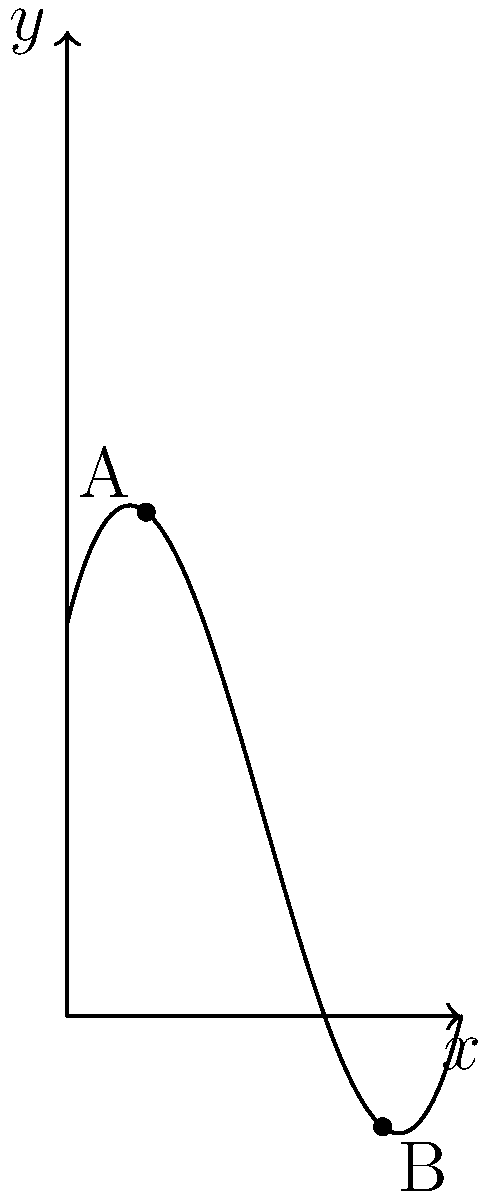As a Ukrainian hiker, you're planning a route through the Carpathian Mountains. The terrain between two points A and B can be modeled by the polynomial function $f(x) = 0.1x^3 - 1.5x^2 + 4x + 10$, where $x$ and $f(x)$ are measured in kilometers. Point A is located at $x=2$ and point B is at $x=8$. What is the shortest distance between these two points along the curve, rounded to the nearest 0.1 km? To find the shortest distance along the curve between two points, we need to calculate the arc length. The formula for arc length is:

$$L = \int_{a}^{b} \sqrt{1 + [f'(x)]^2} dx$$

where $f'(x)$ is the derivative of $f(x)$.

Steps:
1) Find $f'(x)$:
   $f'(x) = 0.3x^2 - 3x + 4$

2) Set up the integral:
   $$L = \int_{2}^{8} \sqrt{1 + (0.3x^2 - 3x + 4)^2} dx$$

3) This integral is complex and cannot be solved analytically. We need to use numerical methods, such as Simpson's Rule or a computer algebra system.

4) Using a numerical integration method, we get:
   $L \approx 7.3498$ km

5) Rounding to the nearest 0.1 km:
   $L \approx 7.3$ km
Answer: 7.3 km 